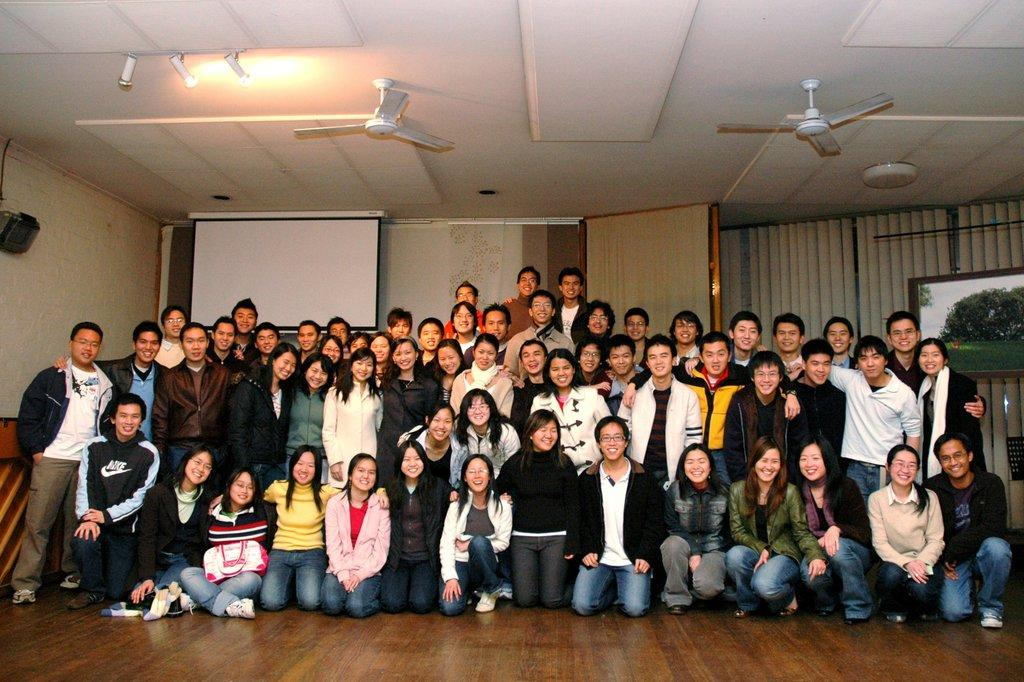What type of surface are the people standing on in the image? The people are standing on a wooden floor in the image. What positions are some of the people in? Some people are laying on their knees in the image. What can be seen at the top of the image? There are lights visible at the top of the image. What devices are visible in the image? There are fans visible in the image. What can be seen in the background of the image? There is a curtain and a screen in the background of the image. What type of cracker is being passed around among friends in the image? There is no cracker or friends present in the image. What is the title of the event taking place in the image? There is no event or title mentioned in the image. 